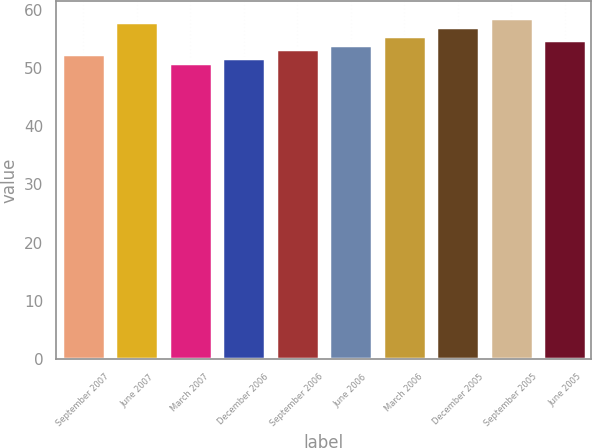Convert chart to OTSL. <chart><loc_0><loc_0><loc_500><loc_500><bar_chart><fcel>September 2007<fcel>June 2007<fcel>March 2007<fcel>December 2006<fcel>September 2006<fcel>June 2006<fcel>March 2006<fcel>December 2005<fcel>September 2005<fcel>June 2005<nl><fcel>52.42<fcel>57.8<fcel>50.9<fcel>51.66<fcel>53.18<fcel>54<fcel>55.52<fcel>57.04<fcel>58.56<fcel>54.76<nl></chart> 